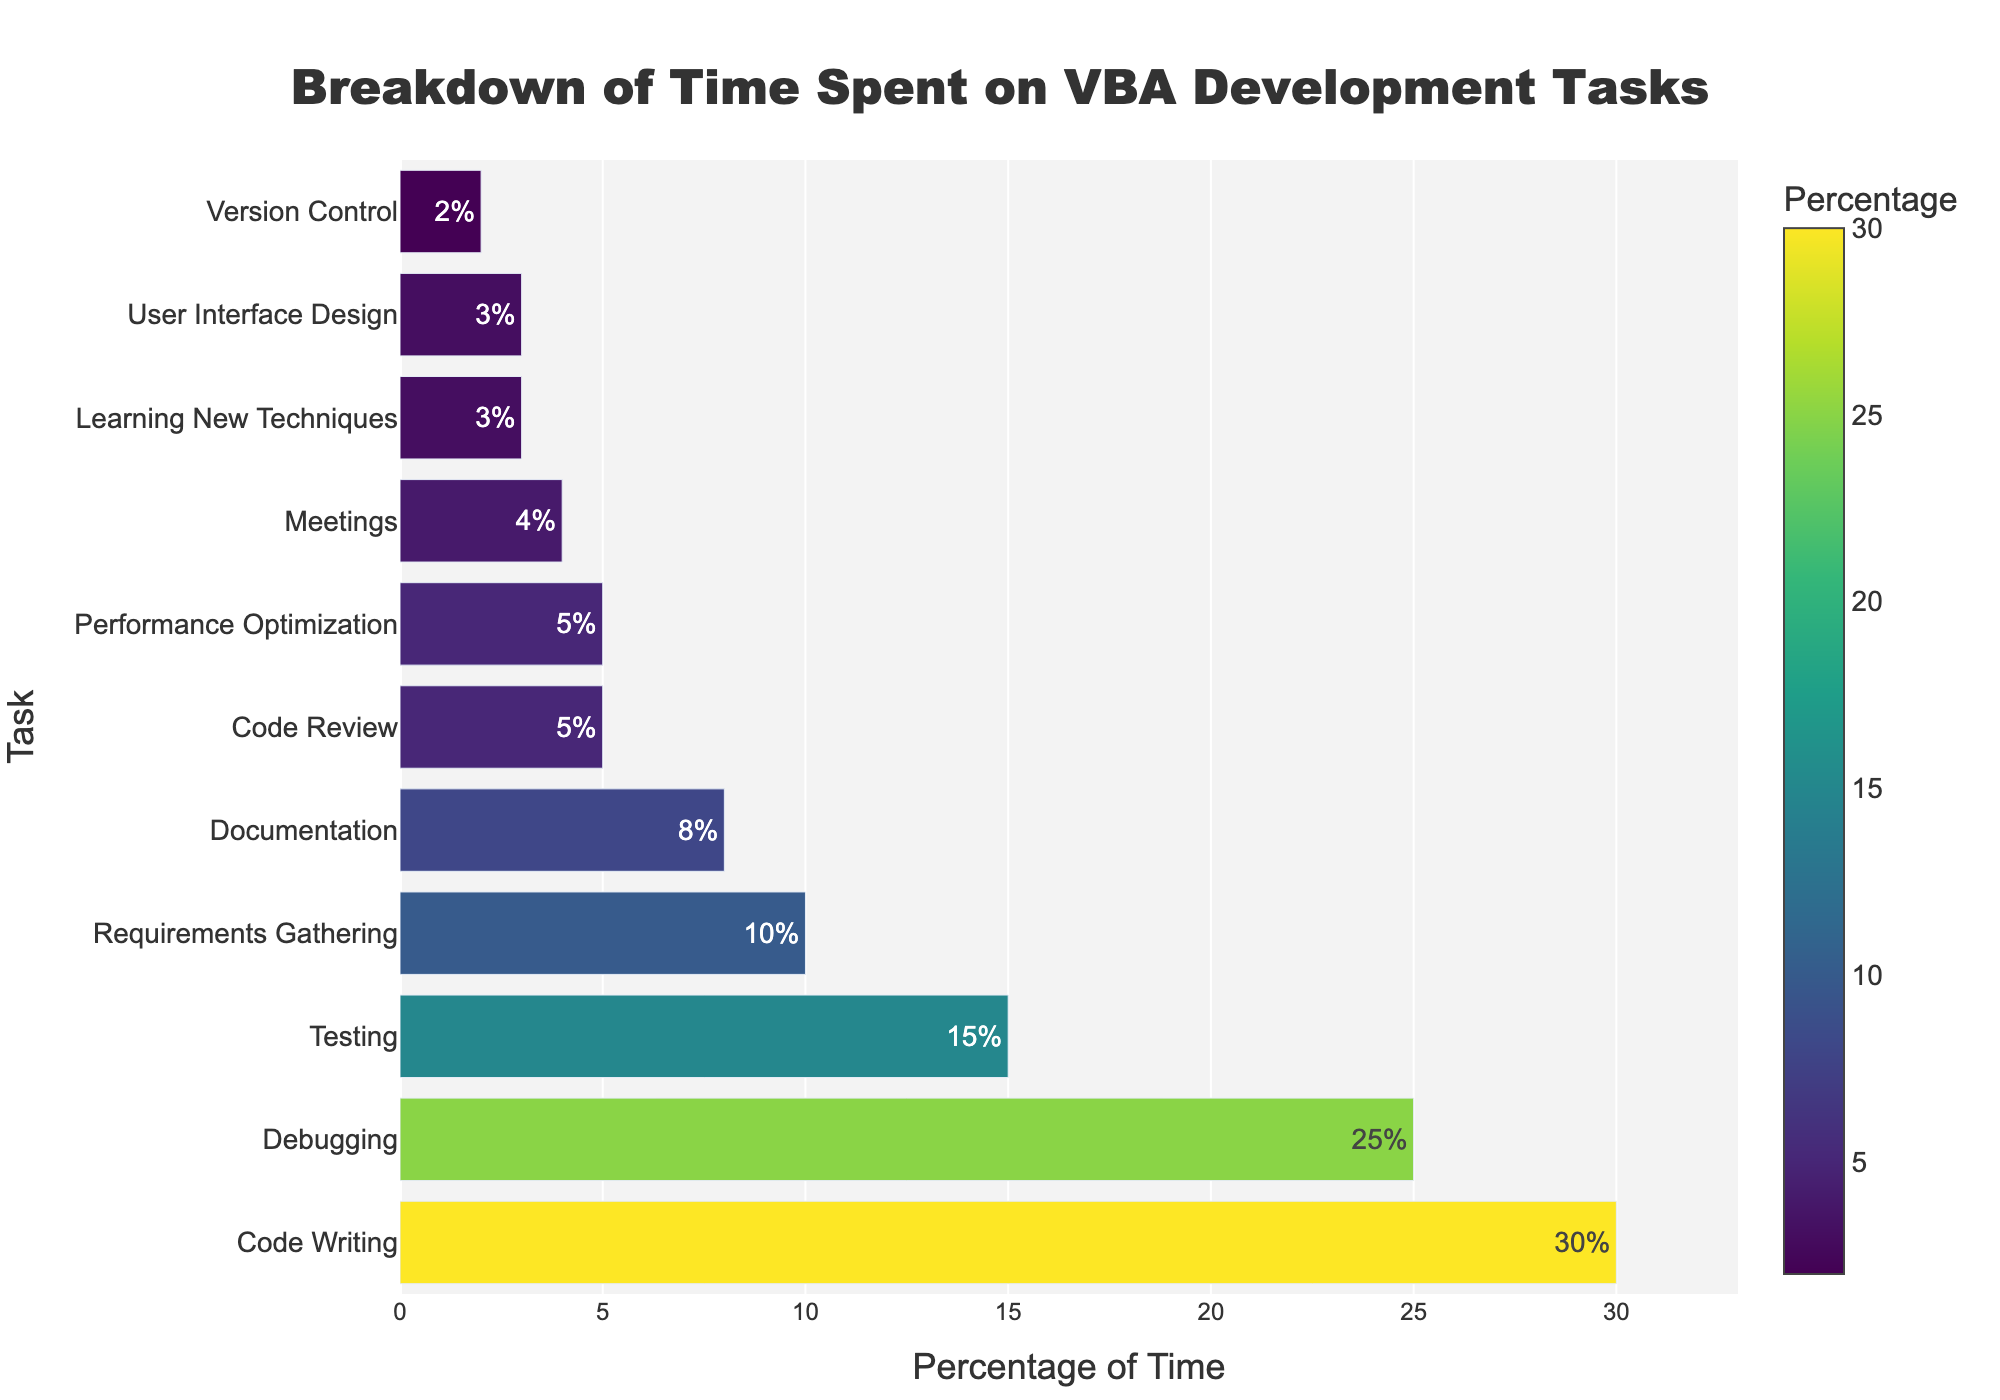What task takes up the largest percentage of time? The figure shows a horizontal bar chart of various tasks with their respective percentages. The longest bar represents "Code Writing" with a percentage of 30%, indicating it is the task that takes up the largest percentage of time.
Answer: Code Writing How much more time is spent on "Debugging" compared to "Meetings"? The percentage of time spent on "Debugging" is 25%, and for "Meetings" it is 4%. The difference is calculated as 25% - 4% = 21%.
Answer: 21% What is the combined percentage of time spent on "Documentation", "Code Review", and "Performance Optimization"? According to the bar chart, "Documentation" takes up 8%, "Code Review" 5%, and "Performance Optimization" 5%. Summing these up gives 8% + 5% + 5% = 18%.
Answer: 18% Which task takes up the smallest percentage of time and what is that percentage? The shortest bar in the chart represents "Version Control," which takes up 2% of the time according to the data.
Answer: Version Control, 2% Is more time spent on "Testing" or "Requirements Gathering"? By comparing the bars for "Testing" and "Requirements Gathering," the chart shows that "Testing" takes up 15% and "Requirements Gathering" takes up 10%, indicating more time is spent on "Testing."
Answer: Testing How much time is spent on both "User Interface Design" and "Learning New Techniques" combined? "User Interface Design" takes up 3% and "Learning New Techniques" also takes up 3%. The combined time spent is 3% + 3% = 6%.
Answer: 6% What is the difference in time percentage between "Code Review" and "Performance Optimization"? The chart shows "Code Review" with 5% and "Performance Optimization" with 5%. The difference is 5% - 5% = 0%.
Answer: 0% If you were to group "Code Writing" and "Debugging" together, what percentage of the overall time would they represent? "Code Writing" takes up 30%, and "Debugging" takes up 25%. Combined, they represent 30% + 25% = 55% of the overall time.
Answer: 55% Which tasks have a percentage of time spent less than or equal to 5%? According to the figure, the tasks are "Code Review" (5%), "Performance Optimization" (5%), "User Interface Design" (3%), "Learning New Techniques" (3%), and "Version Control" (2%).
Answer: Code Review, Performance Optimization, User Interface Design, Learning New Techniques, Version Control 